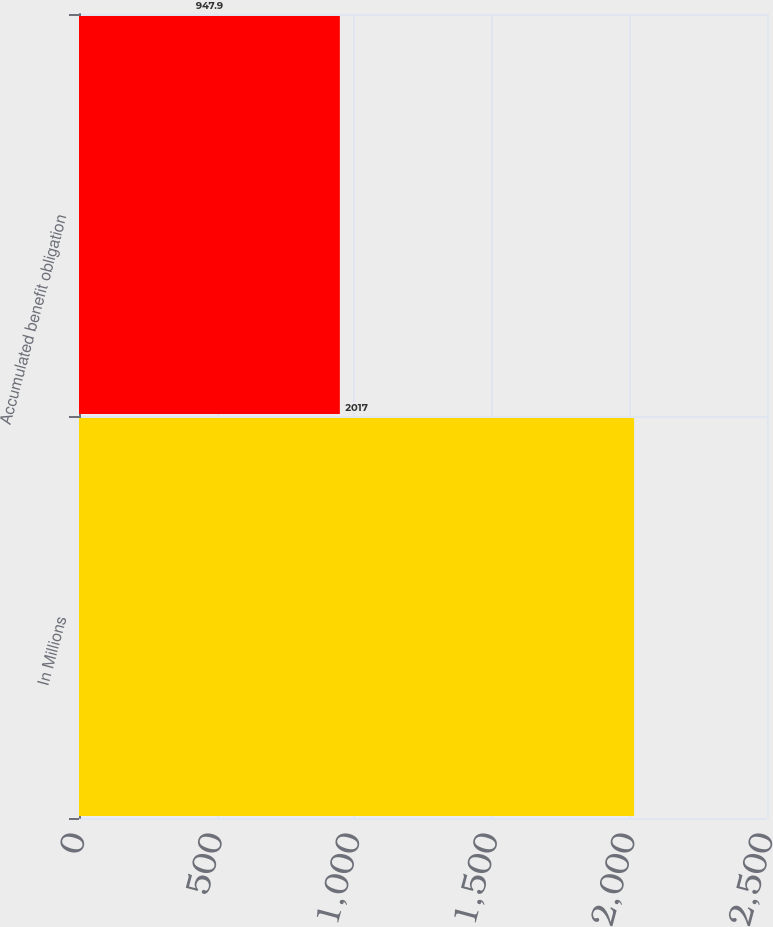Convert chart. <chart><loc_0><loc_0><loc_500><loc_500><bar_chart><fcel>In Millions<fcel>Accumulated benefit obligation<nl><fcel>2017<fcel>947.9<nl></chart> 